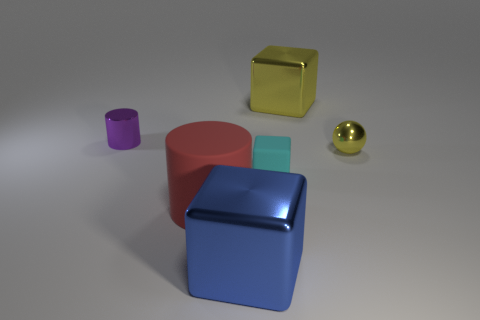Does the shiny cylinder have the same color as the small shiny sphere?
Keep it short and to the point. No. There is a cylinder that is on the right side of the metal thing left of the red cylinder; what number of cyan rubber things are left of it?
Keep it short and to the point. 0. What material is the block behind the small metal thing on the right side of the cyan object made of?
Your answer should be very brief. Metal. Are there any big objects that have the same shape as the small cyan matte object?
Give a very brief answer. Yes. There is a metal object that is the same size as the yellow block; what color is it?
Keep it short and to the point. Blue. How many objects are either cubes in front of the small purple object or objects that are behind the purple thing?
Give a very brief answer. 3. What number of objects are large purple cylinders or small shiny objects?
Offer a very short reply. 2. There is a metallic thing that is both on the left side of the cyan rubber block and on the right side of the big red matte object; what is its size?
Provide a succinct answer. Large. What number of large green balls are the same material as the small purple cylinder?
Offer a very short reply. 0. There is a cube that is the same material as the large cylinder; what color is it?
Provide a succinct answer. Cyan. 